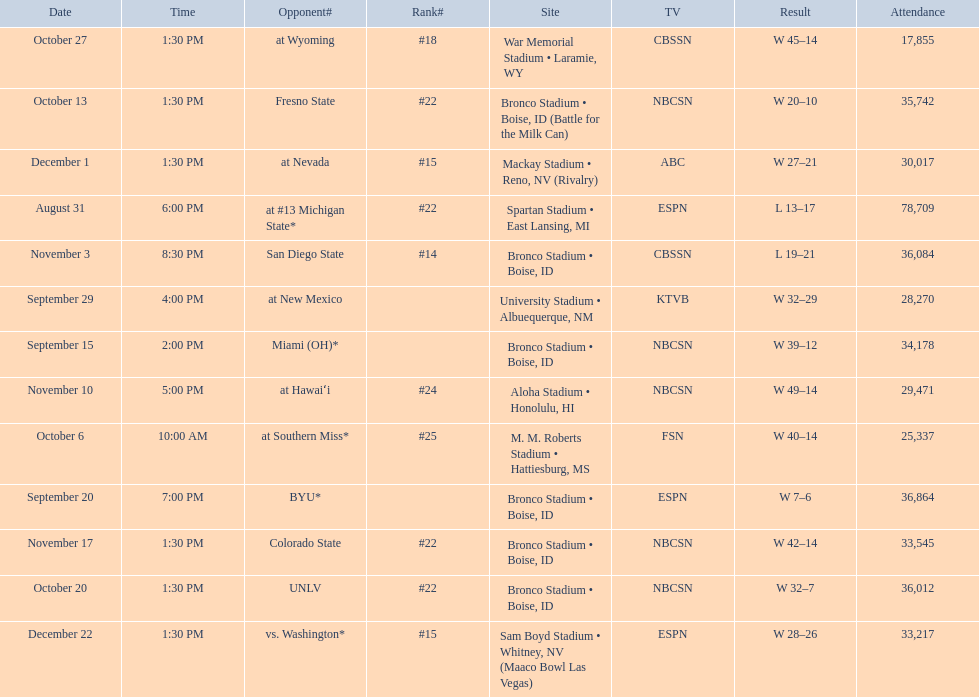Who were all of the opponents? At #13 michigan state*, miami (oh)*, byu*, at new mexico, at southern miss*, fresno state, unlv, at wyoming, san diego state, at hawaiʻi, colorado state, at nevada, vs. washington*. Who did they face on november 3rd? San Diego State. What rank were they on november 3rd? #14. 